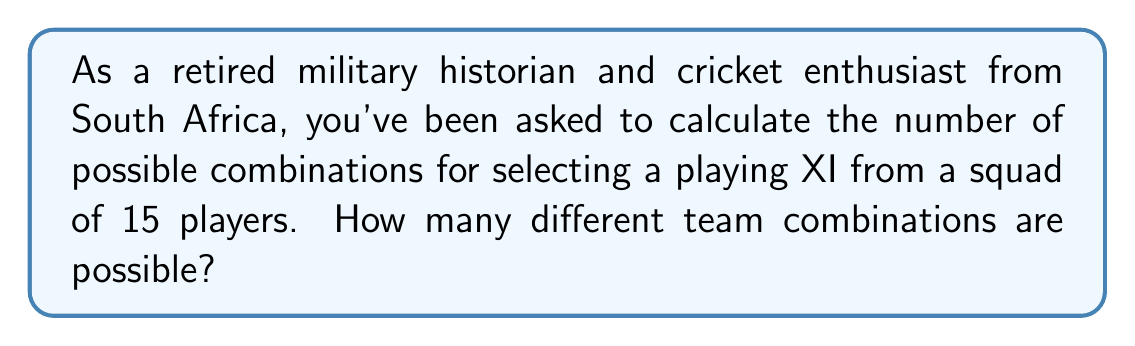Solve this math problem. Let's approach this step-by-step:

1) This is a combination problem. We are selecting 11 players from a group of 15, where the order doesn't matter (as it's just about who's in the team, not their batting order).

2) The formula for combinations is:

   $$C(n,r) = \frac{n!}{r!(n-r)!}$$

   Where $n$ is the total number of items to choose from, and $r$ is the number of items being chosen.

3) In this case, $n = 15$ (total squad size) and $r = 11$ (playing XI).

4) Substituting these values:

   $$C(15,11) = \frac{15!}{11!(15-11)!} = \frac{15!}{11!4!}$$

5) Expanding this:

   $$\frac{15 * 14 * 13 * 12 * 11!}{11! * 4 * 3 * 2 * 1}$$

6) The 11! cancels out in the numerator and denominator:

   $$\frac{15 * 14 * 13 * 12}{4 * 3 * 2 * 1} = \frac{32760}{24} = 1365$$

Therefore, there are 1365 possible combinations for selecting a playing XI from a squad of 15 players.
Answer: 1365 